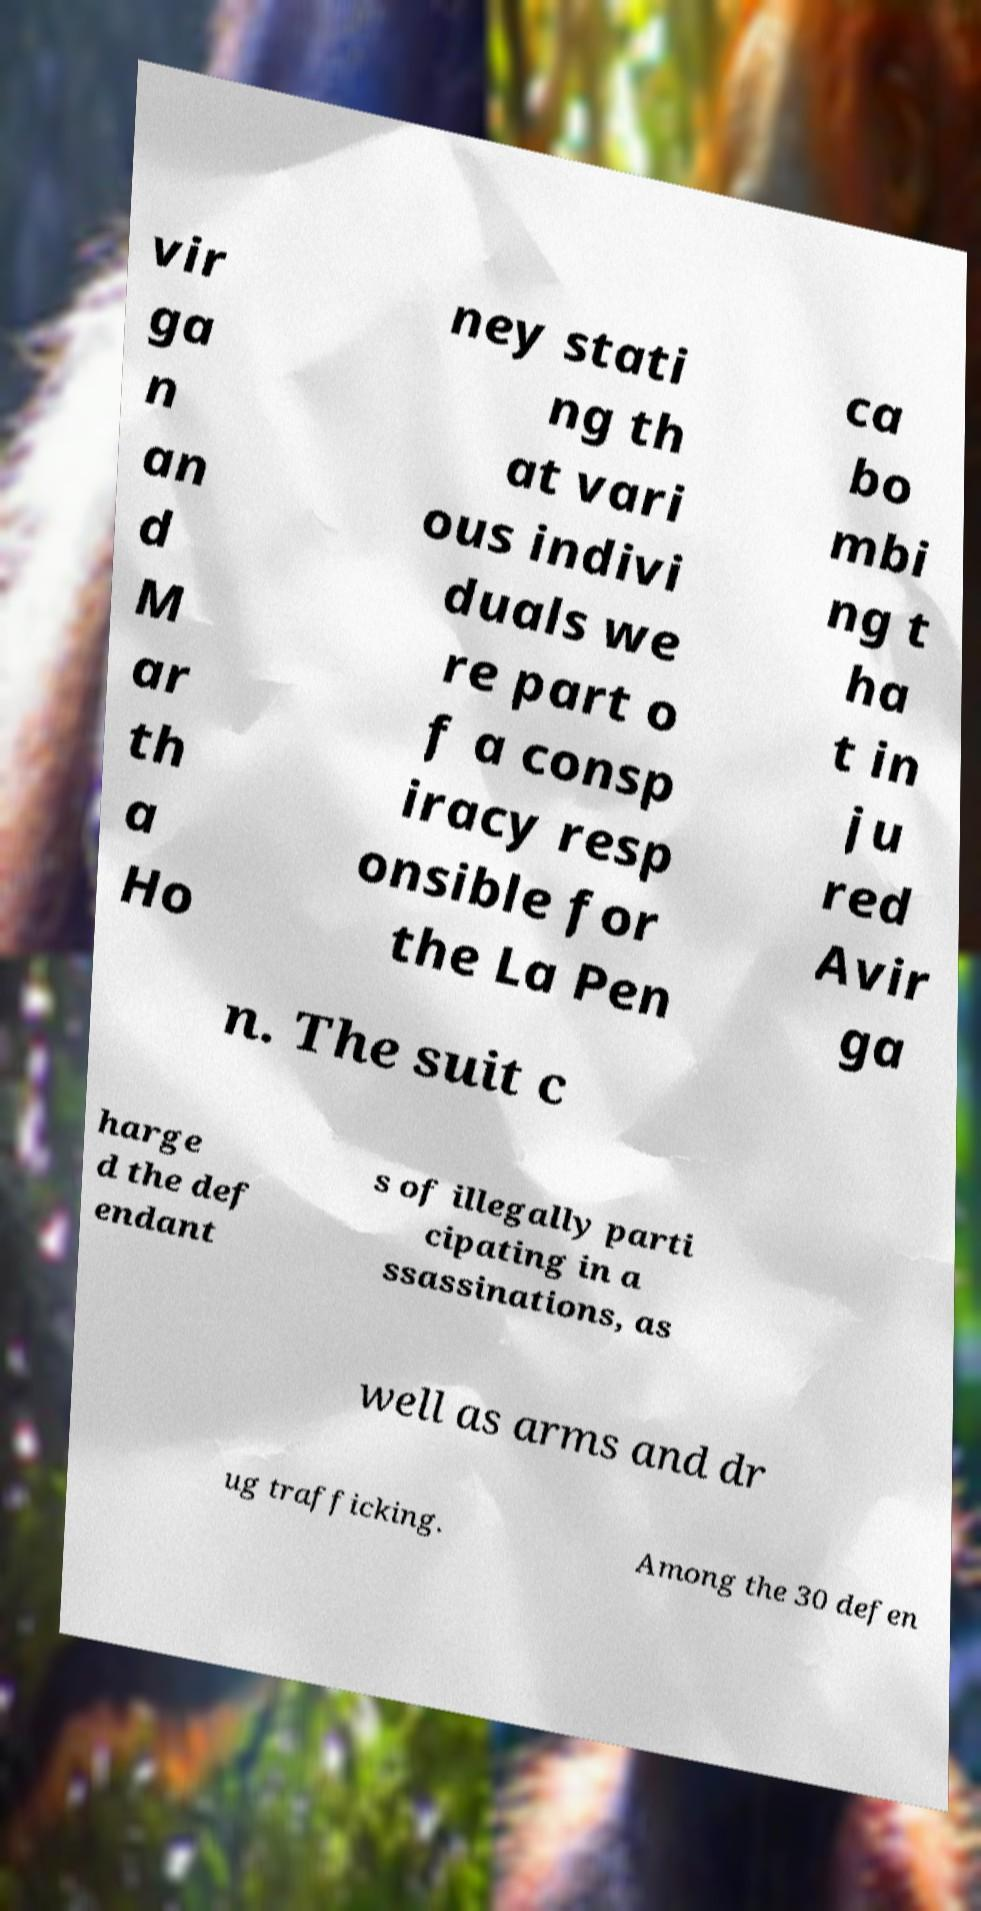Could you assist in decoding the text presented in this image and type it out clearly? vir ga n an d M ar th a Ho ney stati ng th at vari ous indivi duals we re part o f a consp iracy resp onsible for the La Pen ca bo mbi ng t ha t in ju red Avir ga n. The suit c harge d the def endant s of illegally parti cipating in a ssassinations, as well as arms and dr ug trafficking. Among the 30 defen 